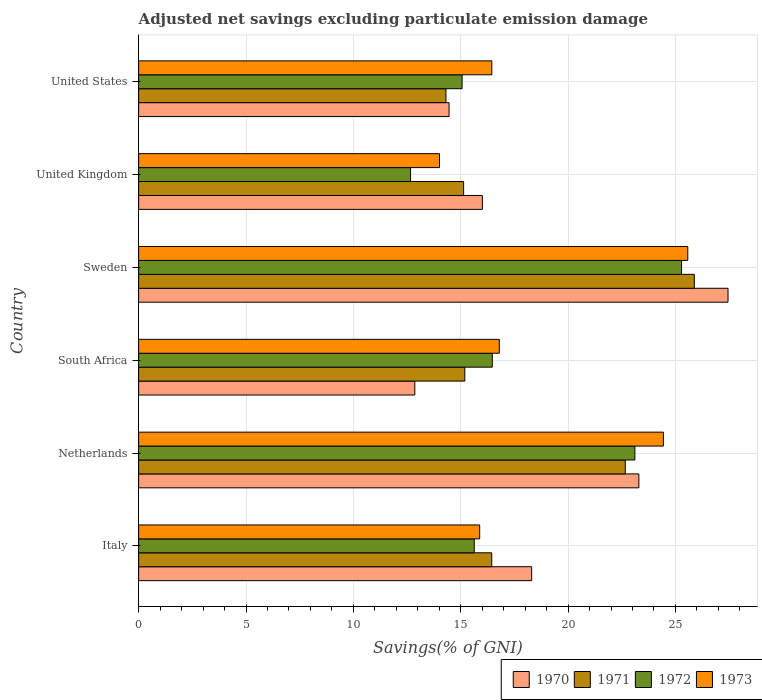Are the number of bars per tick equal to the number of legend labels?
Offer a very short reply. Yes. How many bars are there on the 1st tick from the bottom?
Ensure brevity in your answer.  4. What is the label of the 4th group of bars from the top?
Provide a short and direct response. South Africa. In how many cases, is the number of bars for a given country not equal to the number of legend labels?
Offer a terse response. 0. What is the adjusted net savings in 1970 in Sweden?
Your response must be concise. 27.45. Across all countries, what is the maximum adjusted net savings in 1970?
Your answer should be very brief. 27.45. Across all countries, what is the minimum adjusted net savings in 1972?
Ensure brevity in your answer.  12.66. In which country was the adjusted net savings in 1973 minimum?
Provide a succinct answer. United Kingdom. What is the total adjusted net savings in 1971 in the graph?
Your response must be concise. 109.62. What is the difference between the adjusted net savings in 1971 in South Africa and that in Sweden?
Your answer should be compact. -10.69. What is the difference between the adjusted net savings in 1973 in Italy and the adjusted net savings in 1971 in Sweden?
Keep it short and to the point. -10. What is the average adjusted net savings in 1973 per country?
Offer a very short reply. 18.86. What is the difference between the adjusted net savings in 1973 and adjusted net savings in 1971 in Italy?
Provide a succinct answer. -0.56. In how many countries, is the adjusted net savings in 1970 greater than 25 %?
Ensure brevity in your answer.  1. What is the ratio of the adjusted net savings in 1972 in Netherlands to that in United Kingdom?
Keep it short and to the point. 1.82. Is the adjusted net savings in 1973 in Sweden less than that in United Kingdom?
Offer a terse response. No. What is the difference between the highest and the second highest adjusted net savings in 1972?
Your answer should be very brief. 2.17. What is the difference between the highest and the lowest adjusted net savings in 1973?
Your response must be concise. 11.56. What does the 4th bar from the bottom in United States represents?
Your answer should be very brief. 1973. Is it the case that in every country, the sum of the adjusted net savings in 1970 and adjusted net savings in 1972 is greater than the adjusted net savings in 1973?
Your answer should be very brief. Yes. How many bars are there?
Ensure brevity in your answer.  24. Are the values on the major ticks of X-axis written in scientific E-notation?
Offer a terse response. No. Does the graph contain any zero values?
Ensure brevity in your answer.  No. Does the graph contain grids?
Keep it short and to the point. Yes. How many legend labels are there?
Offer a very short reply. 4. What is the title of the graph?
Provide a succinct answer. Adjusted net savings excluding particulate emission damage. What is the label or title of the X-axis?
Your response must be concise. Savings(% of GNI). What is the Savings(% of GNI) in 1970 in Italy?
Your answer should be very brief. 18.3. What is the Savings(% of GNI) in 1971 in Italy?
Give a very brief answer. 16.44. What is the Savings(% of GNI) in 1972 in Italy?
Provide a short and direct response. 15.63. What is the Savings(% of GNI) of 1973 in Italy?
Make the answer very short. 15.88. What is the Savings(% of GNI) in 1970 in Netherlands?
Offer a terse response. 23.3. What is the Savings(% of GNI) in 1971 in Netherlands?
Offer a very short reply. 22.66. What is the Savings(% of GNI) of 1972 in Netherlands?
Offer a very short reply. 23.11. What is the Savings(% of GNI) of 1973 in Netherlands?
Make the answer very short. 24.44. What is the Savings(% of GNI) of 1970 in South Africa?
Give a very brief answer. 12.86. What is the Savings(% of GNI) of 1971 in South Africa?
Offer a terse response. 15.19. What is the Savings(% of GNI) in 1972 in South Africa?
Keep it short and to the point. 16.47. What is the Savings(% of GNI) in 1973 in South Africa?
Your answer should be compact. 16.8. What is the Savings(% of GNI) in 1970 in Sweden?
Make the answer very short. 27.45. What is the Savings(% of GNI) of 1971 in Sweden?
Offer a very short reply. 25.88. What is the Savings(% of GNI) in 1972 in Sweden?
Provide a short and direct response. 25.28. What is the Savings(% of GNI) of 1973 in Sweden?
Offer a very short reply. 25.57. What is the Savings(% of GNI) of 1970 in United Kingdom?
Offer a very short reply. 16.01. What is the Savings(% of GNI) in 1971 in United Kingdom?
Provide a succinct answer. 15.13. What is the Savings(% of GNI) in 1972 in United Kingdom?
Provide a succinct answer. 12.66. What is the Savings(% of GNI) in 1973 in United Kingdom?
Give a very brief answer. 14.01. What is the Savings(% of GNI) in 1970 in United States?
Your answer should be very brief. 14.46. What is the Savings(% of GNI) of 1971 in United States?
Ensure brevity in your answer.  14.31. What is the Savings(% of GNI) in 1972 in United States?
Give a very brief answer. 15.06. What is the Savings(% of GNI) in 1973 in United States?
Make the answer very short. 16.45. Across all countries, what is the maximum Savings(% of GNI) in 1970?
Your response must be concise. 27.45. Across all countries, what is the maximum Savings(% of GNI) of 1971?
Give a very brief answer. 25.88. Across all countries, what is the maximum Savings(% of GNI) in 1972?
Make the answer very short. 25.28. Across all countries, what is the maximum Savings(% of GNI) of 1973?
Provide a succinct answer. 25.57. Across all countries, what is the minimum Savings(% of GNI) of 1970?
Your answer should be compact. 12.86. Across all countries, what is the minimum Savings(% of GNI) in 1971?
Provide a short and direct response. 14.31. Across all countries, what is the minimum Savings(% of GNI) of 1972?
Offer a very short reply. 12.66. Across all countries, what is the minimum Savings(% of GNI) in 1973?
Provide a short and direct response. 14.01. What is the total Savings(% of GNI) in 1970 in the graph?
Keep it short and to the point. 112.37. What is the total Savings(% of GNI) of 1971 in the graph?
Keep it short and to the point. 109.62. What is the total Savings(% of GNI) of 1972 in the graph?
Give a very brief answer. 108.22. What is the total Savings(% of GNI) of 1973 in the graph?
Provide a succinct answer. 113.15. What is the difference between the Savings(% of GNI) in 1970 in Italy and that in Netherlands?
Offer a terse response. -4.99. What is the difference between the Savings(% of GNI) of 1971 in Italy and that in Netherlands?
Your answer should be very brief. -6.22. What is the difference between the Savings(% of GNI) in 1972 in Italy and that in Netherlands?
Provide a short and direct response. -7.48. What is the difference between the Savings(% of GNI) of 1973 in Italy and that in Netherlands?
Provide a short and direct response. -8.56. What is the difference between the Savings(% of GNI) in 1970 in Italy and that in South Africa?
Ensure brevity in your answer.  5.44. What is the difference between the Savings(% of GNI) in 1971 in Italy and that in South Africa?
Provide a succinct answer. 1.25. What is the difference between the Savings(% of GNI) of 1972 in Italy and that in South Africa?
Keep it short and to the point. -0.84. What is the difference between the Savings(% of GNI) in 1973 in Italy and that in South Africa?
Make the answer very short. -0.91. What is the difference between the Savings(% of GNI) in 1970 in Italy and that in Sweden?
Your answer should be compact. -9.14. What is the difference between the Savings(% of GNI) in 1971 in Italy and that in Sweden?
Offer a terse response. -9.43. What is the difference between the Savings(% of GNI) of 1972 in Italy and that in Sweden?
Ensure brevity in your answer.  -9.65. What is the difference between the Savings(% of GNI) in 1973 in Italy and that in Sweden?
Keep it short and to the point. -9.69. What is the difference between the Savings(% of GNI) of 1970 in Italy and that in United Kingdom?
Ensure brevity in your answer.  2.3. What is the difference between the Savings(% of GNI) in 1971 in Italy and that in United Kingdom?
Offer a terse response. 1.31. What is the difference between the Savings(% of GNI) of 1972 in Italy and that in United Kingdom?
Ensure brevity in your answer.  2.97. What is the difference between the Savings(% of GNI) in 1973 in Italy and that in United Kingdom?
Your response must be concise. 1.87. What is the difference between the Savings(% of GNI) in 1970 in Italy and that in United States?
Offer a terse response. 3.85. What is the difference between the Savings(% of GNI) of 1971 in Italy and that in United States?
Give a very brief answer. 2.13. What is the difference between the Savings(% of GNI) of 1972 in Italy and that in United States?
Give a very brief answer. 0.57. What is the difference between the Savings(% of GNI) of 1973 in Italy and that in United States?
Ensure brevity in your answer.  -0.56. What is the difference between the Savings(% of GNI) of 1970 in Netherlands and that in South Africa?
Offer a very short reply. 10.43. What is the difference between the Savings(% of GNI) in 1971 in Netherlands and that in South Africa?
Keep it short and to the point. 7.47. What is the difference between the Savings(% of GNI) in 1972 in Netherlands and that in South Africa?
Offer a terse response. 6.64. What is the difference between the Savings(% of GNI) in 1973 in Netherlands and that in South Africa?
Ensure brevity in your answer.  7.64. What is the difference between the Savings(% of GNI) in 1970 in Netherlands and that in Sweden?
Ensure brevity in your answer.  -4.15. What is the difference between the Savings(% of GNI) of 1971 in Netherlands and that in Sweden?
Keep it short and to the point. -3.21. What is the difference between the Savings(% of GNI) in 1972 in Netherlands and that in Sweden?
Provide a succinct answer. -2.17. What is the difference between the Savings(% of GNI) in 1973 in Netherlands and that in Sweden?
Give a very brief answer. -1.14. What is the difference between the Savings(% of GNI) of 1970 in Netherlands and that in United Kingdom?
Give a very brief answer. 7.29. What is the difference between the Savings(% of GNI) of 1971 in Netherlands and that in United Kingdom?
Your answer should be compact. 7.53. What is the difference between the Savings(% of GNI) of 1972 in Netherlands and that in United Kingdom?
Your response must be concise. 10.45. What is the difference between the Savings(% of GNI) in 1973 in Netherlands and that in United Kingdom?
Offer a terse response. 10.43. What is the difference between the Savings(% of GNI) of 1970 in Netherlands and that in United States?
Keep it short and to the point. 8.84. What is the difference between the Savings(% of GNI) in 1971 in Netherlands and that in United States?
Offer a terse response. 8.35. What is the difference between the Savings(% of GNI) of 1972 in Netherlands and that in United States?
Provide a short and direct response. 8.05. What is the difference between the Savings(% of GNI) of 1973 in Netherlands and that in United States?
Offer a very short reply. 7.99. What is the difference between the Savings(% of GNI) of 1970 in South Africa and that in Sweden?
Give a very brief answer. -14.59. What is the difference between the Savings(% of GNI) in 1971 in South Africa and that in Sweden?
Offer a very short reply. -10.69. What is the difference between the Savings(% of GNI) of 1972 in South Africa and that in Sweden?
Provide a succinct answer. -8.81. What is the difference between the Savings(% of GNI) in 1973 in South Africa and that in Sweden?
Provide a succinct answer. -8.78. What is the difference between the Savings(% of GNI) of 1970 in South Africa and that in United Kingdom?
Offer a very short reply. -3.15. What is the difference between the Savings(% of GNI) in 1971 in South Africa and that in United Kingdom?
Offer a terse response. 0.06. What is the difference between the Savings(% of GNI) in 1972 in South Africa and that in United Kingdom?
Provide a succinct answer. 3.81. What is the difference between the Savings(% of GNI) in 1973 in South Africa and that in United Kingdom?
Provide a succinct answer. 2.78. What is the difference between the Savings(% of GNI) of 1970 in South Africa and that in United States?
Offer a terse response. -1.59. What is the difference between the Savings(% of GNI) in 1971 in South Africa and that in United States?
Provide a short and direct response. 0.88. What is the difference between the Savings(% of GNI) of 1972 in South Africa and that in United States?
Make the answer very short. 1.41. What is the difference between the Savings(% of GNI) in 1973 in South Africa and that in United States?
Ensure brevity in your answer.  0.35. What is the difference between the Savings(% of GNI) of 1970 in Sweden and that in United Kingdom?
Keep it short and to the point. 11.44. What is the difference between the Savings(% of GNI) in 1971 in Sweden and that in United Kingdom?
Offer a terse response. 10.74. What is the difference between the Savings(% of GNI) of 1972 in Sweden and that in United Kingdom?
Keep it short and to the point. 12.62. What is the difference between the Savings(% of GNI) in 1973 in Sweden and that in United Kingdom?
Provide a short and direct response. 11.56. What is the difference between the Savings(% of GNI) in 1970 in Sweden and that in United States?
Ensure brevity in your answer.  12.99. What is the difference between the Savings(% of GNI) in 1971 in Sweden and that in United States?
Offer a very short reply. 11.57. What is the difference between the Savings(% of GNI) of 1972 in Sweden and that in United States?
Provide a short and direct response. 10.22. What is the difference between the Savings(% of GNI) of 1973 in Sweden and that in United States?
Make the answer very short. 9.13. What is the difference between the Savings(% of GNI) of 1970 in United Kingdom and that in United States?
Your response must be concise. 1.55. What is the difference between the Savings(% of GNI) of 1971 in United Kingdom and that in United States?
Your answer should be compact. 0.82. What is the difference between the Savings(% of GNI) in 1972 in United Kingdom and that in United States?
Offer a terse response. -2.4. What is the difference between the Savings(% of GNI) in 1973 in United Kingdom and that in United States?
Make the answer very short. -2.43. What is the difference between the Savings(% of GNI) of 1970 in Italy and the Savings(% of GNI) of 1971 in Netherlands?
Give a very brief answer. -4.36. What is the difference between the Savings(% of GNI) in 1970 in Italy and the Savings(% of GNI) in 1972 in Netherlands?
Your response must be concise. -4.81. What is the difference between the Savings(% of GNI) of 1970 in Italy and the Savings(% of GNI) of 1973 in Netherlands?
Keep it short and to the point. -6.13. What is the difference between the Savings(% of GNI) of 1971 in Italy and the Savings(% of GNI) of 1972 in Netherlands?
Ensure brevity in your answer.  -6.67. What is the difference between the Savings(% of GNI) of 1971 in Italy and the Savings(% of GNI) of 1973 in Netherlands?
Provide a short and direct response. -7.99. What is the difference between the Savings(% of GNI) in 1972 in Italy and the Savings(% of GNI) in 1973 in Netherlands?
Make the answer very short. -8.81. What is the difference between the Savings(% of GNI) in 1970 in Italy and the Savings(% of GNI) in 1971 in South Africa?
Your response must be concise. 3.11. What is the difference between the Savings(% of GNI) of 1970 in Italy and the Savings(% of GNI) of 1972 in South Africa?
Your answer should be compact. 1.83. What is the difference between the Savings(% of GNI) of 1970 in Italy and the Savings(% of GNI) of 1973 in South Africa?
Make the answer very short. 1.51. What is the difference between the Savings(% of GNI) of 1971 in Italy and the Savings(% of GNI) of 1972 in South Africa?
Ensure brevity in your answer.  -0.03. What is the difference between the Savings(% of GNI) of 1971 in Italy and the Savings(% of GNI) of 1973 in South Africa?
Provide a succinct answer. -0.35. What is the difference between the Savings(% of GNI) of 1972 in Italy and the Savings(% of GNI) of 1973 in South Africa?
Provide a short and direct response. -1.17. What is the difference between the Savings(% of GNI) in 1970 in Italy and the Savings(% of GNI) in 1971 in Sweden?
Your answer should be compact. -7.57. What is the difference between the Savings(% of GNI) of 1970 in Italy and the Savings(% of GNI) of 1972 in Sweden?
Offer a very short reply. -6.98. What is the difference between the Savings(% of GNI) in 1970 in Italy and the Savings(% of GNI) in 1973 in Sweden?
Your response must be concise. -7.27. What is the difference between the Savings(% of GNI) of 1971 in Italy and the Savings(% of GNI) of 1972 in Sweden?
Your answer should be very brief. -8.84. What is the difference between the Savings(% of GNI) of 1971 in Italy and the Savings(% of GNI) of 1973 in Sweden?
Ensure brevity in your answer.  -9.13. What is the difference between the Savings(% of GNI) of 1972 in Italy and the Savings(% of GNI) of 1973 in Sweden?
Give a very brief answer. -9.94. What is the difference between the Savings(% of GNI) in 1970 in Italy and the Savings(% of GNI) in 1971 in United Kingdom?
Offer a very short reply. 3.17. What is the difference between the Savings(% of GNI) of 1970 in Italy and the Savings(% of GNI) of 1972 in United Kingdom?
Offer a terse response. 5.64. What is the difference between the Savings(% of GNI) in 1970 in Italy and the Savings(% of GNI) in 1973 in United Kingdom?
Offer a terse response. 4.29. What is the difference between the Savings(% of GNI) of 1971 in Italy and the Savings(% of GNI) of 1972 in United Kingdom?
Provide a succinct answer. 3.78. What is the difference between the Savings(% of GNI) of 1971 in Italy and the Savings(% of GNI) of 1973 in United Kingdom?
Your answer should be very brief. 2.43. What is the difference between the Savings(% of GNI) in 1972 in Italy and the Savings(% of GNI) in 1973 in United Kingdom?
Your answer should be compact. 1.62. What is the difference between the Savings(% of GNI) of 1970 in Italy and the Savings(% of GNI) of 1971 in United States?
Keep it short and to the point. 3.99. What is the difference between the Savings(% of GNI) in 1970 in Italy and the Savings(% of GNI) in 1972 in United States?
Your answer should be compact. 3.24. What is the difference between the Savings(% of GNI) in 1970 in Italy and the Savings(% of GNI) in 1973 in United States?
Give a very brief answer. 1.86. What is the difference between the Savings(% of GNI) in 1971 in Italy and the Savings(% of GNI) in 1972 in United States?
Give a very brief answer. 1.38. What is the difference between the Savings(% of GNI) in 1971 in Italy and the Savings(% of GNI) in 1973 in United States?
Offer a terse response. -0. What is the difference between the Savings(% of GNI) in 1972 in Italy and the Savings(% of GNI) in 1973 in United States?
Offer a terse response. -0.82. What is the difference between the Savings(% of GNI) of 1970 in Netherlands and the Savings(% of GNI) of 1971 in South Africa?
Make the answer very short. 8.11. What is the difference between the Savings(% of GNI) of 1970 in Netherlands and the Savings(% of GNI) of 1972 in South Africa?
Your response must be concise. 6.83. What is the difference between the Savings(% of GNI) of 1970 in Netherlands and the Savings(% of GNI) of 1973 in South Africa?
Keep it short and to the point. 6.5. What is the difference between the Savings(% of GNI) in 1971 in Netherlands and the Savings(% of GNI) in 1972 in South Africa?
Make the answer very short. 6.19. What is the difference between the Savings(% of GNI) of 1971 in Netherlands and the Savings(% of GNI) of 1973 in South Africa?
Offer a very short reply. 5.87. What is the difference between the Savings(% of GNI) in 1972 in Netherlands and the Savings(% of GNI) in 1973 in South Africa?
Make the answer very short. 6.31. What is the difference between the Savings(% of GNI) of 1970 in Netherlands and the Savings(% of GNI) of 1971 in Sweden?
Your answer should be compact. -2.58. What is the difference between the Savings(% of GNI) in 1970 in Netherlands and the Savings(% of GNI) in 1972 in Sweden?
Your response must be concise. -1.99. What is the difference between the Savings(% of GNI) in 1970 in Netherlands and the Savings(% of GNI) in 1973 in Sweden?
Provide a short and direct response. -2.28. What is the difference between the Savings(% of GNI) of 1971 in Netherlands and the Savings(% of GNI) of 1972 in Sweden?
Give a very brief answer. -2.62. What is the difference between the Savings(% of GNI) in 1971 in Netherlands and the Savings(% of GNI) in 1973 in Sweden?
Ensure brevity in your answer.  -2.91. What is the difference between the Savings(% of GNI) of 1972 in Netherlands and the Savings(% of GNI) of 1973 in Sweden?
Ensure brevity in your answer.  -2.46. What is the difference between the Savings(% of GNI) of 1970 in Netherlands and the Savings(% of GNI) of 1971 in United Kingdom?
Provide a succinct answer. 8.16. What is the difference between the Savings(% of GNI) in 1970 in Netherlands and the Savings(% of GNI) in 1972 in United Kingdom?
Give a very brief answer. 10.63. What is the difference between the Savings(% of GNI) of 1970 in Netherlands and the Savings(% of GNI) of 1973 in United Kingdom?
Ensure brevity in your answer.  9.28. What is the difference between the Savings(% of GNI) in 1971 in Netherlands and the Savings(% of GNI) in 1972 in United Kingdom?
Your answer should be very brief. 10. What is the difference between the Savings(% of GNI) in 1971 in Netherlands and the Savings(% of GNI) in 1973 in United Kingdom?
Offer a very short reply. 8.65. What is the difference between the Savings(% of GNI) in 1972 in Netherlands and the Savings(% of GNI) in 1973 in United Kingdom?
Make the answer very short. 9.1. What is the difference between the Savings(% of GNI) of 1970 in Netherlands and the Savings(% of GNI) of 1971 in United States?
Your answer should be compact. 8.98. What is the difference between the Savings(% of GNI) of 1970 in Netherlands and the Savings(% of GNI) of 1972 in United States?
Provide a succinct answer. 8.23. What is the difference between the Savings(% of GNI) of 1970 in Netherlands and the Savings(% of GNI) of 1973 in United States?
Offer a very short reply. 6.85. What is the difference between the Savings(% of GNI) of 1971 in Netherlands and the Savings(% of GNI) of 1972 in United States?
Make the answer very short. 7.6. What is the difference between the Savings(% of GNI) in 1971 in Netherlands and the Savings(% of GNI) in 1973 in United States?
Your answer should be very brief. 6.22. What is the difference between the Savings(% of GNI) in 1972 in Netherlands and the Savings(% of GNI) in 1973 in United States?
Give a very brief answer. 6.66. What is the difference between the Savings(% of GNI) of 1970 in South Africa and the Savings(% of GNI) of 1971 in Sweden?
Provide a succinct answer. -13.02. What is the difference between the Savings(% of GNI) of 1970 in South Africa and the Savings(% of GNI) of 1972 in Sweden?
Provide a short and direct response. -12.42. What is the difference between the Savings(% of GNI) of 1970 in South Africa and the Savings(% of GNI) of 1973 in Sweden?
Your answer should be very brief. -12.71. What is the difference between the Savings(% of GNI) of 1971 in South Africa and the Savings(% of GNI) of 1972 in Sweden?
Your answer should be compact. -10.09. What is the difference between the Savings(% of GNI) of 1971 in South Africa and the Savings(% of GNI) of 1973 in Sweden?
Keep it short and to the point. -10.38. What is the difference between the Savings(% of GNI) of 1972 in South Africa and the Savings(% of GNI) of 1973 in Sweden?
Provide a short and direct response. -9.1. What is the difference between the Savings(% of GNI) of 1970 in South Africa and the Savings(% of GNI) of 1971 in United Kingdom?
Offer a very short reply. -2.27. What is the difference between the Savings(% of GNI) of 1970 in South Africa and the Savings(% of GNI) of 1972 in United Kingdom?
Offer a very short reply. 0.2. What is the difference between the Savings(% of GNI) in 1970 in South Africa and the Savings(% of GNI) in 1973 in United Kingdom?
Your answer should be compact. -1.15. What is the difference between the Savings(% of GNI) of 1971 in South Africa and the Savings(% of GNI) of 1972 in United Kingdom?
Your answer should be compact. 2.53. What is the difference between the Savings(% of GNI) of 1971 in South Africa and the Savings(% of GNI) of 1973 in United Kingdom?
Provide a short and direct response. 1.18. What is the difference between the Savings(% of GNI) of 1972 in South Africa and the Savings(% of GNI) of 1973 in United Kingdom?
Your answer should be compact. 2.46. What is the difference between the Savings(% of GNI) in 1970 in South Africa and the Savings(% of GNI) in 1971 in United States?
Keep it short and to the point. -1.45. What is the difference between the Savings(% of GNI) in 1970 in South Africa and the Savings(% of GNI) in 1972 in United States?
Ensure brevity in your answer.  -2.2. What is the difference between the Savings(% of GNI) of 1970 in South Africa and the Savings(% of GNI) of 1973 in United States?
Offer a terse response. -3.58. What is the difference between the Savings(% of GNI) of 1971 in South Africa and the Savings(% of GNI) of 1972 in United States?
Provide a succinct answer. 0.13. What is the difference between the Savings(% of GNI) of 1971 in South Africa and the Savings(% of GNI) of 1973 in United States?
Offer a terse response. -1.26. What is the difference between the Savings(% of GNI) of 1972 in South Africa and the Savings(% of GNI) of 1973 in United States?
Your answer should be compact. 0.02. What is the difference between the Savings(% of GNI) of 1970 in Sweden and the Savings(% of GNI) of 1971 in United Kingdom?
Provide a short and direct response. 12.31. What is the difference between the Savings(% of GNI) of 1970 in Sweden and the Savings(% of GNI) of 1972 in United Kingdom?
Give a very brief answer. 14.78. What is the difference between the Savings(% of GNI) in 1970 in Sweden and the Savings(% of GNI) in 1973 in United Kingdom?
Provide a succinct answer. 13.44. What is the difference between the Savings(% of GNI) in 1971 in Sweden and the Savings(% of GNI) in 1972 in United Kingdom?
Ensure brevity in your answer.  13.21. What is the difference between the Savings(% of GNI) of 1971 in Sweden and the Savings(% of GNI) of 1973 in United Kingdom?
Provide a succinct answer. 11.87. What is the difference between the Savings(% of GNI) of 1972 in Sweden and the Savings(% of GNI) of 1973 in United Kingdom?
Your response must be concise. 11.27. What is the difference between the Savings(% of GNI) of 1970 in Sweden and the Savings(% of GNI) of 1971 in United States?
Provide a short and direct response. 13.14. What is the difference between the Savings(% of GNI) in 1970 in Sweden and the Savings(% of GNI) in 1972 in United States?
Provide a succinct answer. 12.38. What is the difference between the Savings(% of GNI) of 1970 in Sweden and the Savings(% of GNI) of 1973 in United States?
Offer a very short reply. 11. What is the difference between the Savings(% of GNI) in 1971 in Sweden and the Savings(% of GNI) in 1972 in United States?
Make the answer very short. 10.81. What is the difference between the Savings(% of GNI) of 1971 in Sweden and the Savings(% of GNI) of 1973 in United States?
Keep it short and to the point. 9.43. What is the difference between the Savings(% of GNI) of 1972 in Sweden and the Savings(% of GNI) of 1973 in United States?
Offer a very short reply. 8.84. What is the difference between the Savings(% of GNI) of 1970 in United Kingdom and the Savings(% of GNI) of 1971 in United States?
Offer a terse response. 1.7. What is the difference between the Savings(% of GNI) of 1970 in United Kingdom and the Savings(% of GNI) of 1972 in United States?
Make the answer very short. 0.94. What is the difference between the Savings(% of GNI) in 1970 in United Kingdom and the Savings(% of GNI) in 1973 in United States?
Keep it short and to the point. -0.44. What is the difference between the Savings(% of GNI) in 1971 in United Kingdom and the Savings(% of GNI) in 1972 in United States?
Ensure brevity in your answer.  0.07. What is the difference between the Savings(% of GNI) of 1971 in United Kingdom and the Savings(% of GNI) of 1973 in United States?
Provide a succinct answer. -1.31. What is the difference between the Savings(% of GNI) in 1972 in United Kingdom and the Savings(% of GNI) in 1973 in United States?
Offer a terse response. -3.78. What is the average Savings(% of GNI) of 1970 per country?
Make the answer very short. 18.73. What is the average Savings(% of GNI) of 1971 per country?
Your answer should be very brief. 18.27. What is the average Savings(% of GNI) of 1972 per country?
Offer a very short reply. 18.04. What is the average Savings(% of GNI) of 1973 per country?
Keep it short and to the point. 18.86. What is the difference between the Savings(% of GNI) in 1970 and Savings(% of GNI) in 1971 in Italy?
Your response must be concise. 1.86. What is the difference between the Savings(% of GNI) of 1970 and Savings(% of GNI) of 1972 in Italy?
Offer a very short reply. 2.67. What is the difference between the Savings(% of GNI) of 1970 and Savings(% of GNI) of 1973 in Italy?
Keep it short and to the point. 2.42. What is the difference between the Savings(% of GNI) in 1971 and Savings(% of GNI) in 1972 in Italy?
Your answer should be compact. 0.81. What is the difference between the Savings(% of GNI) of 1971 and Savings(% of GNI) of 1973 in Italy?
Your answer should be very brief. 0.56. What is the difference between the Savings(% of GNI) in 1972 and Savings(% of GNI) in 1973 in Italy?
Provide a short and direct response. -0.25. What is the difference between the Savings(% of GNI) in 1970 and Savings(% of GNI) in 1971 in Netherlands?
Offer a terse response. 0.63. What is the difference between the Savings(% of GNI) in 1970 and Savings(% of GNI) in 1972 in Netherlands?
Your answer should be very brief. 0.19. What is the difference between the Savings(% of GNI) in 1970 and Savings(% of GNI) in 1973 in Netherlands?
Keep it short and to the point. -1.14. What is the difference between the Savings(% of GNI) of 1971 and Savings(% of GNI) of 1972 in Netherlands?
Provide a succinct answer. -0.45. What is the difference between the Savings(% of GNI) of 1971 and Savings(% of GNI) of 1973 in Netherlands?
Ensure brevity in your answer.  -1.77. What is the difference between the Savings(% of GNI) of 1972 and Savings(% of GNI) of 1973 in Netherlands?
Provide a short and direct response. -1.33. What is the difference between the Savings(% of GNI) of 1970 and Savings(% of GNI) of 1971 in South Africa?
Offer a very short reply. -2.33. What is the difference between the Savings(% of GNI) in 1970 and Savings(% of GNI) in 1972 in South Africa?
Provide a short and direct response. -3.61. What is the difference between the Savings(% of GNI) in 1970 and Savings(% of GNI) in 1973 in South Africa?
Your answer should be compact. -3.93. What is the difference between the Savings(% of GNI) in 1971 and Savings(% of GNI) in 1972 in South Africa?
Provide a short and direct response. -1.28. What is the difference between the Savings(% of GNI) of 1971 and Savings(% of GNI) of 1973 in South Africa?
Your answer should be very brief. -1.61. What is the difference between the Savings(% of GNI) of 1972 and Savings(% of GNI) of 1973 in South Africa?
Offer a terse response. -0.33. What is the difference between the Savings(% of GNI) in 1970 and Savings(% of GNI) in 1971 in Sweden?
Offer a terse response. 1.57. What is the difference between the Savings(% of GNI) in 1970 and Savings(% of GNI) in 1972 in Sweden?
Provide a short and direct response. 2.16. What is the difference between the Savings(% of GNI) of 1970 and Savings(% of GNI) of 1973 in Sweden?
Ensure brevity in your answer.  1.87. What is the difference between the Savings(% of GNI) of 1971 and Savings(% of GNI) of 1972 in Sweden?
Your response must be concise. 0.59. What is the difference between the Savings(% of GNI) in 1971 and Savings(% of GNI) in 1973 in Sweden?
Offer a very short reply. 0.3. What is the difference between the Savings(% of GNI) in 1972 and Savings(% of GNI) in 1973 in Sweden?
Give a very brief answer. -0.29. What is the difference between the Savings(% of GNI) of 1970 and Savings(% of GNI) of 1971 in United Kingdom?
Your answer should be compact. 0.87. What is the difference between the Savings(% of GNI) in 1970 and Savings(% of GNI) in 1972 in United Kingdom?
Your response must be concise. 3.34. What is the difference between the Savings(% of GNI) of 1970 and Savings(% of GNI) of 1973 in United Kingdom?
Offer a very short reply. 2. What is the difference between the Savings(% of GNI) of 1971 and Savings(% of GNI) of 1972 in United Kingdom?
Your answer should be very brief. 2.47. What is the difference between the Savings(% of GNI) in 1971 and Savings(% of GNI) in 1973 in United Kingdom?
Your response must be concise. 1.12. What is the difference between the Savings(% of GNI) in 1972 and Savings(% of GNI) in 1973 in United Kingdom?
Keep it short and to the point. -1.35. What is the difference between the Savings(% of GNI) in 1970 and Savings(% of GNI) in 1971 in United States?
Your answer should be compact. 0.14. What is the difference between the Savings(% of GNI) of 1970 and Savings(% of GNI) of 1972 in United States?
Keep it short and to the point. -0.61. What is the difference between the Savings(% of GNI) of 1970 and Savings(% of GNI) of 1973 in United States?
Ensure brevity in your answer.  -1.99. What is the difference between the Savings(% of GNI) of 1971 and Savings(% of GNI) of 1972 in United States?
Make the answer very short. -0.75. What is the difference between the Savings(% of GNI) in 1971 and Savings(% of GNI) in 1973 in United States?
Ensure brevity in your answer.  -2.13. What is the difference between the Savings(% of GNI) in 1972 and Savings(% of GNI) in 1973 in United States?
Your answer should be very brief. -1.38. What is the ratio of the Savings(% of GNI) in 1970 in Italy to that in Netherlands?
Your response must be concise. 0.79. What is the ratio of the Savings(% of GNI) of 1971 in Italy to that in Netherlands?
Provide a succinct answer. 0.73. What is the ratio of the Savings(% of GNI) in 1972 in Italy to that in Netherlands?
Give a very brief answer. 0.68. What is the ratio of the Savings(% of GNI) in 1973 in Italy to that in Netherlands?
Offer a terse response. 0.65. What is the ratio of the Savings(% of GNI) of 1970 in Italy to that in South Africa?
Keep it short and to the point. 1.42. What is the ratio of the Savings(% of GNI) in 1971 in Italy to that in South Africa?
Make the answer very short. 1.08. What is the ratio of the Savings(% of GNI) of 1972 in Italy to that in South Africa?
Provide a short and direct response. 0.95. What is the ratio of the Savings(% of GNI) of 1973 in Italy to that in South Africa?
Ensure brevity in your answer.  0.95. What is the ratio of the Savings(% of GNI) of 1970 in Italy to that in Sweden?
Ensure brevity in your answer.  0.67. What is the ratio of the Savings(% of GNI) of 1971 in Italy to that in Sweden?
Offer a terse response. 0.64. What is the ratio of the Savings(% of GNI) of 1972 in Italy to that in Sweden?
Your answer should be compact. 0.62. What is the ratio of the Savings(% of GNI) in 1973 in Italy to that in Sweden?
Provide a short and direct response. 0.62. What is the ratio of the Savings(% of GNI) of 1970 in Italy to that in United Kingdom?
Make the answer very short. 1.14. What is the ratio of the Savings(% of GNI) in 1971 in Italy to that in United Kingdom?
Ensure brevity in your answer.  1.09. What is the ratio of the Savings(% of GNI) in 1972 in Italy to that in United Kingdom?
Ensure brevity in your answer.  1.23. What is the ratio of the Savings(% of GNI) in 1973 in Italy to that in United Kingdom?
Provide a short and direct response. 1.13. What is the ratio of the Savings(% of GNI) in 1970 in Italy to that in United States?
Give a very brief answer. 1.27. What is the ratio of the Savings(% of GNI) of 1971 in Italy to that in United States?
Offer a terse response. 1.15. What is the ratio of the Savings(% of GNI) in 1972 in Italy to that in United States?
Give a very brief answer. 1.04. What is the ratio of the Savings(% of GNI) of 1973 in Italy to that in United States?
Your answer should be compact. 0.97. What is the ratio of the Savings(% of GNI) in 1970 in Netherlands to that in South Africa?
Provide a short and direct response. 1.81. What is the ratio of the Savings(% of GNI) of 1971 in Netherlands to that in South Africa?
Your answer should be compact. 1.49. What is the ratio of the Savings(% of GNI) in 1972 in Netherlands to that in South Africa?
Provide a succinct answer. 1.4. What is the ratio of the Savings(% of GNI) in 1973 in Netherlands to that in South Africa?
Ensure brevity in your answer.  1.46. What is the ratio of the Savings(% of GNI) of 1970 in Netherlands to that in Sweden?
Ensure brevity in your answer.  0.85. What is the ratio of the Savings(% of GNI) in 1971 in Netherlands to that in Sweden?
Make the answer very short. 0.88. What is the ratio of the Savings(% of GNI) of 1972 in Netherlands to that in Sweden?
Make the answer very short. 0.91. What is the ratio of the Savings(% of GNI) in 1973 in Netherlands to that in Sweden?
Keep it short and to the point. 0.96. What is the ratio of the Savings(% of GNI) of 1970 in Netherlands to that in United Kingdom?
Give a very brief answer. 1.46. What is the ratio of the Savings(% of GNI) of 1971 in Netherlands to that in United Kingdom?
Keep it short and to the point. 1.5. What is the ratio of the Savings(% of GNI) in 1972 in Netherlands to that in United Kingdom?
Your answer should be very brief. 1.82. What is the ratio of the Savings(% of GNI) of 1973 in Netherlands to that in United Kingdom?
Your answer should be very brief. 1.74. What is the ratio of the Savings(% of GNI) of 1970 in Netherlands to that in United States?
Make the answer very short. 1.61. What is the ratio of the Savings(% of GNI) of 1971 in Netherlands to that in United States?
Offer a very short reply. 1.58. What is the ratio of the Savings(% of GNI) in 1972 in Netherlands to that in United States?
Ensure brevity in your answer.  1.53. What is the ratio of the Savings(% of GNI) in 1973 in Netherlands to that in United States?
Your response must be concise. 1.49. What is the ratio of the Savings(% of GNI) in 1970 in South Africa to that in Sweden?
Give a very brief answer. 0.47. What is the ratio of the Savings(% of GNI) in 1971 in South Africa to that in Sweden?
Your response must be concise. 0.59. What is the ratio of the Savings(% of GNI) of 1972 in South Africa to that in Sweden?
Provide a succinct answer. 0.65. What is the ratio of the Savings(% of GNI) of 1973 in South Africa to that in Sweden?
Ensure brevity in your answer.  0.66. What is the ratio of the Savings(% of GNI) in 1970 in South Africa to that in United Kingdom?
Your response must be concise. 0.8. What is the ratio of the Savings(% of GNI) of 1972 in South Africa to that in United Kingdom?
Your answer should be compact. 1.3. What is the ratio of the Savings(% of GNI) in 1973 in South Africa to that in United Kingdom?
Offer a very short reply. 1.2. What is the ratio of the Savings(% of GNI) in 1970 in South Africa to that in United States?
Offer a terse response. 0.89. What is the ratio of the Savings(% of GNI) in 1971 in South Africa to that in United States?
Make the answer very short. 1.06. What is the ratio of the Savings(% of GNI) of 1972 in South Africa to that in United States?
Provide a succinct answer. 1.09. What is the ratio of the Savings(% of GNI) in 1973 in South Africa to that in United States?
Offer a very short reply. 1.02. What is the ratio of the Savings(% of GNI) in 1970 in Sweden to that in United Kingdom?
Make the answer very short. 1.71. What is the ratio of the Savings(% of GNI) in 1971 in Sweden to that in United Kingdom?
Provide a succinct answer. 1.71. What is the ratio of the Savings(% of GNI) in 1972 in Sweden to that in United Kingdom?
Your response must be concise. 2. What is the ratio of the Savings(% of GNI) in 1973 in Sweden to that in United Kingdom?
Give a very brief answer. 1.83. What is the ratio of the Savings(% of GNI) of 1970 in Sweden to that in United States?
Give a very brief answer. 1.9. What is the ratio of the Savings(% of GNI) of 1971 in Sweden to that in United States?
Your answer should be compact. 1.81. What is the ratio of the Savings(% of GNI) of 1972 in Sweden to that in United States?
Provide a succinct answer. 1.68. What is the ratio of the Savings(% of GNI) of 1973 in Sweden to that in United States?
Your answer should be compact. 1.55. What is the ratio of the Savings(% of GNI) in 1970 in United Kingdom to that in United States?
Your response must be concise. 1.11. What is the ratio of the Savings(% of GNI) in 1971 in United Kingdom to that in United States?
Ensure brevity in your answer.  1.06. What is the ratio of the Savings(% of GNI) in 1972 in United Kingdom to that in United States?
Provide a short and direct response. 0.84. What is the ratio of the Savings(% of GNI) in 1973 in United Kingdom to that in United States?
Give a very brief answer. 0.85. What is the difference between the highest and the second highest Savings(% of GNI) in 1970?
Your answer should be very brief. 4.15. What is the difference between the highest and the second highest Savings(% of GNI) in 1971?
Offer a very short reply. 3.21. What is the difference between the highest and the second highest Savings(% of GNI) in 1972?
Your answer should be compact. 2.17. What is the difference between the highest and the second highest Savings(% of GNI) in 1973?
Provide a short and direct response. 1.14. What is the difference between the highest and the lowest Savings(% of GNI) of 1970?
Offer a terse response. 14.59. What is the difference between the highest and the lowest Savings(% of GNI) of 1971?
Give a very brief answer. 11.57. What is the difference between the highest and the lowest Savings(% of GNI) of 1972?
Offer a terse response. 12.62. What is the difference between the highest and the lowest Savings(% of GNI) of 1973?
Your answer should be very brief. 11.56. 